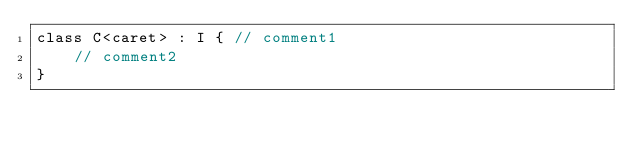<code> <loc_0><loc_0><loc_500><loc_500><_Kotlin_>class C<caret> : I { // comment1
    // comment2
}
</code> 